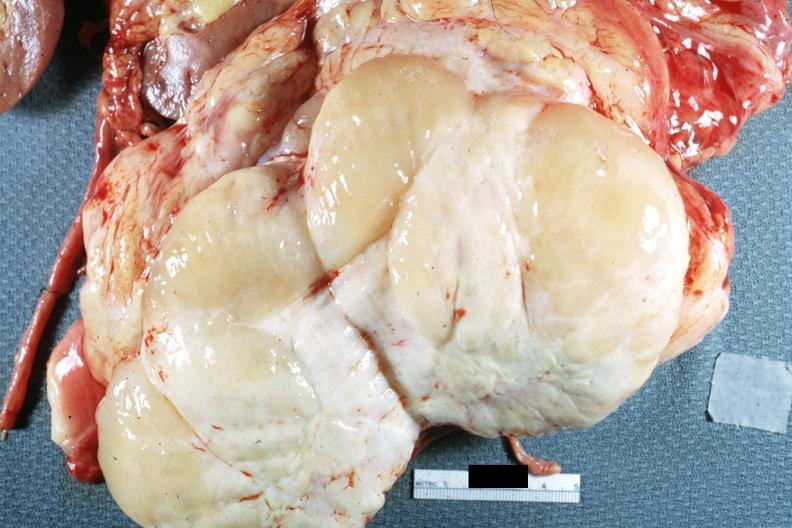what does this image show?
Answer the question using a single word or phrase. Nodular tumor cut surface natural color yellow and white typical gross sarcoma 